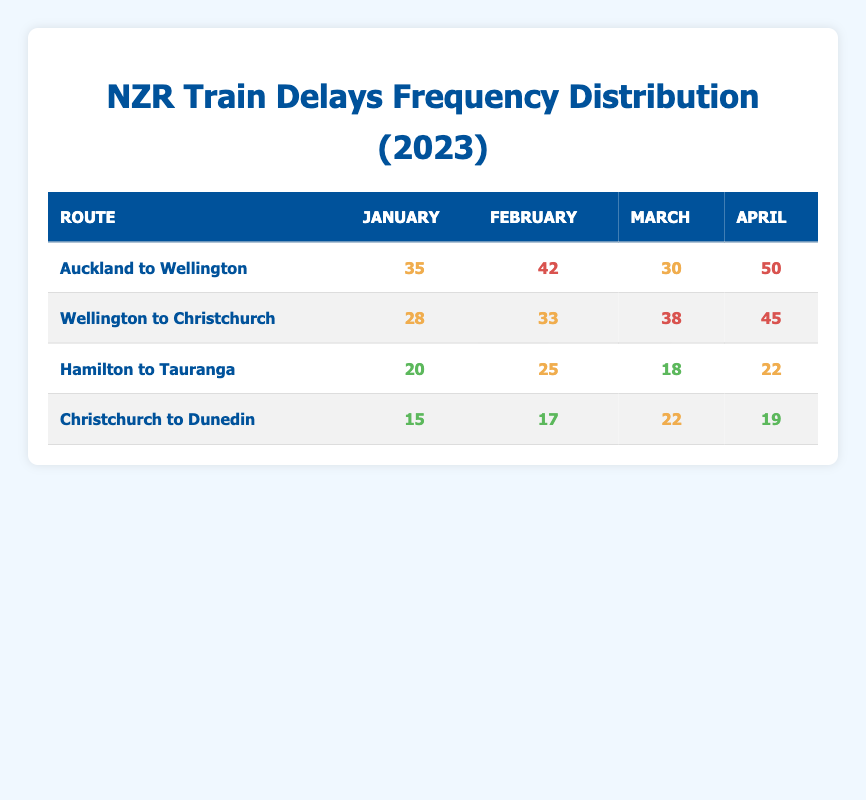What is the highest number of delays recorded for the Auckland to Wellington route? In the table, the delays for the Auckland to Wellington route are 35 in January, 42 in February, 30 in March, and 50 in April. Among these values, 50 is the highest.
Answer: 50 Which route had the lowest delays in January? In January, the delays for each route are as follows: Auckland to Wellington (35), Wellington to Christchurch (28), Hamilton to Tauranga (20), and Christchurch to Dunedin (15). The values indicate that Christchurch to Dunedin has the lowest delay.
Answer: 15 What is the average number of delays for the Wellington to Christchurch route over the four months? The delays for Wellington to Christchurch are 28 (January), 33 (February), 38 (March), and 45 (April). To calculate the average, sum these values: 28 + 33 + 38 + 45 = 144. The average is then 144 divided by 4, which is 36.
Answer: 36 Did the Hamilton to Tauranga route experience more delays in April or January? In January, Hamilton to Tauranga had 20 delays, while in April it had 22 delays. Since 22 is greater than 20, Hamilton to Tauranga experienced more delays in April.
Answer: Yes What is the difference in delays between February and March for the Christchurch to Dunedin route? For Christchurch to Dunedin, the delays are 17 in February and 22 in March. The difference is calculated by subtracting February's delays from March's: 22 - 17 = 5.
Answer: 5 Which month showed the highest delays for any route? To identify the month with the highest delays, we must look at all the recorded delays: January (50 for Auckland to Wellington), February (42 for Auckland to Wellington), March (38 for Wellington to Christchurch), and April (50 for Auckland to Wellington). The highest is 50 in both January and April.
Answer: January and April What is the total number of delays recorded for the Hamilton to Tauranga route in the first quarter (January to March)? The delays for Hamilton to Tauranga in January, February, and March are 20, 25, and 18, respectively. To find the total, sum these values: 20 + 25 + 18 = 63.
Answer: 63 Was the average delay for Auckland to Wellington higher than that of Hamilton to Tauranga? The average delays for Auckland to Wellington are (35 + 42 + 30 + 50) / 4 = 39.25, while for Hamilton to Tauranga, they are (20 + 25 + 18 + 22) / 4 = 21.25. Since 39.25 is greater than 21.25, Auckland to Wellington had a higher average delay.
Answer: Yes 